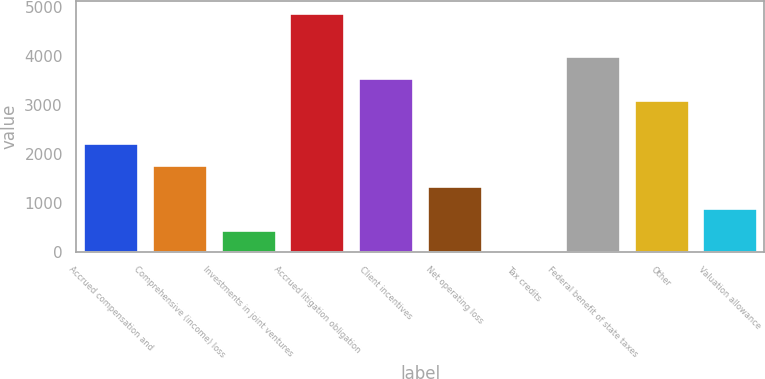Convert chart. <chart><loc_0><loc_0><loc_500><loc_500><bar_chart><fcel>Accrued compensation and<fcel>Comprehensive (income) loss<fcel>Investments in joint ventures<fcel>Accrued litigation obligation<fcel>Client incentives<fcel>Net operating loss<fcel>Tax credits<fcel>Federal benefit of state taxes<fcel>Other<fcel>Valuation allowance<nl><fcel>2216.5<fcel>1773.4<fcel>444.1<fcel>4875.1<fcel>3545.8<fcel>1330.3<fcel>1<fcel>3988.9<fcel>3102.7<fcel>887.2<nl></chart> 